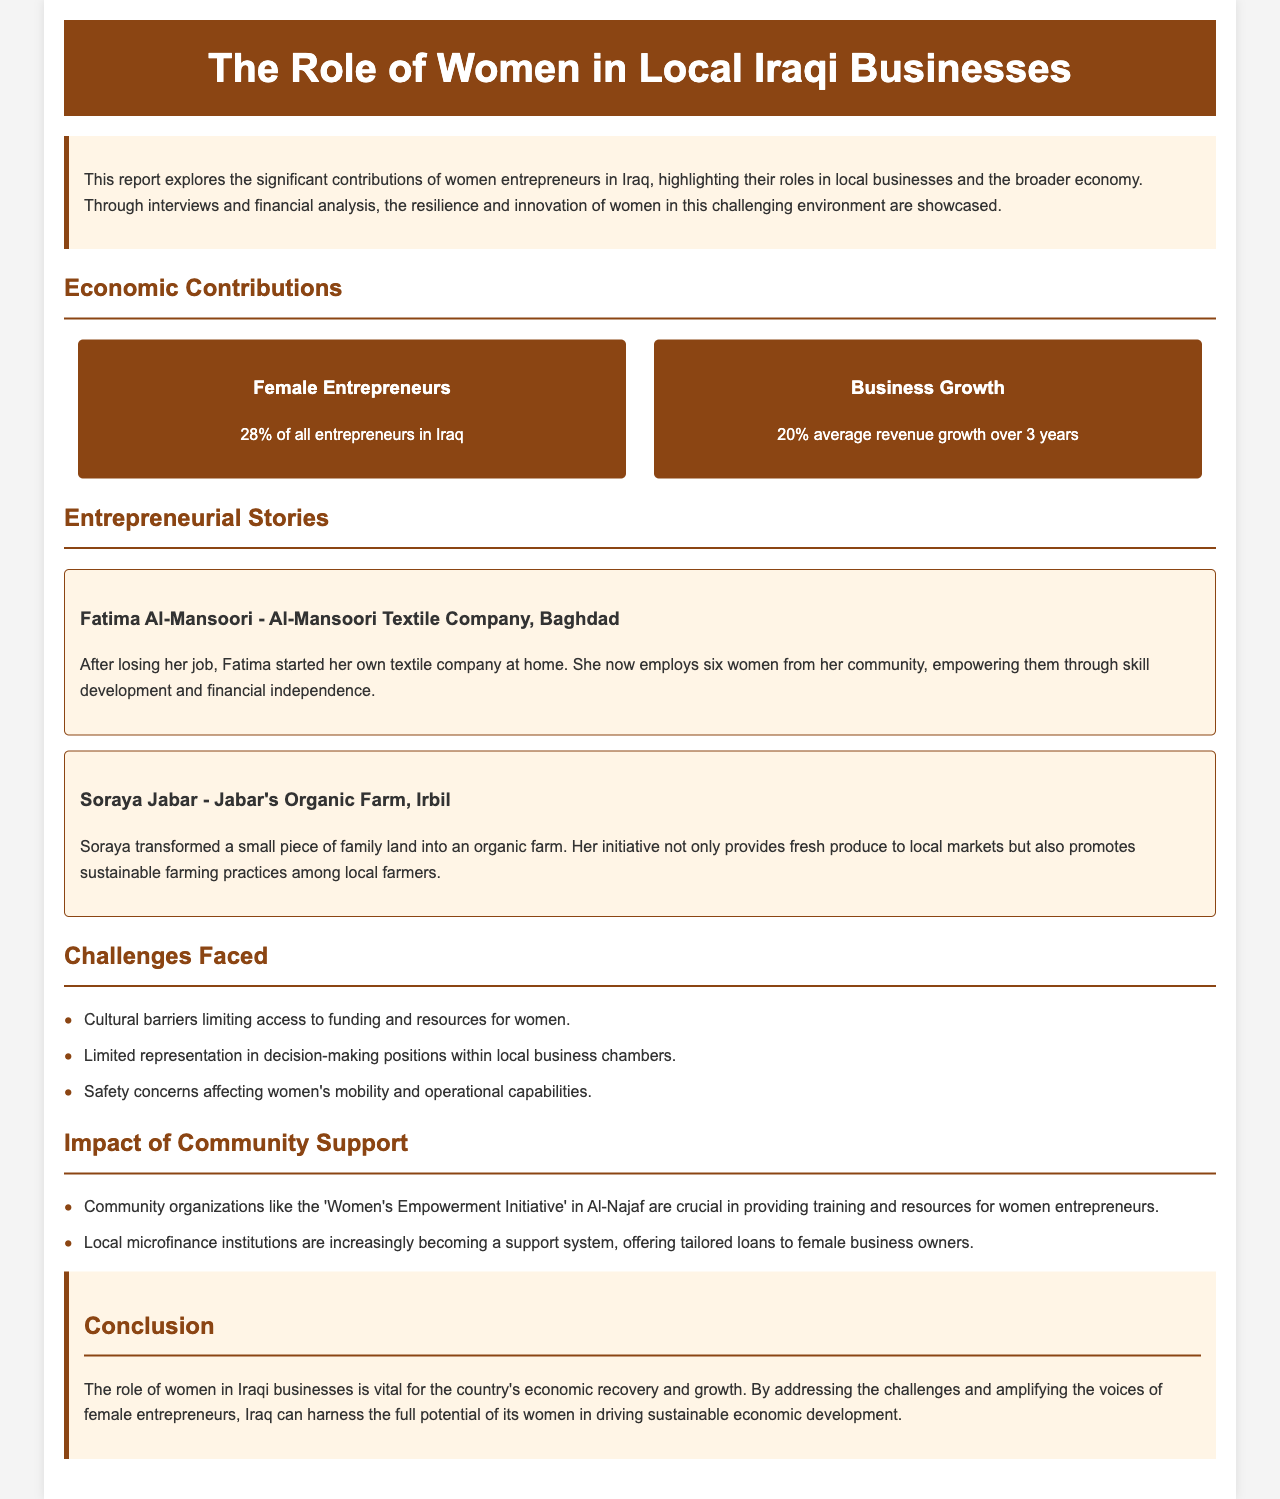What percentage of entrepreneurs in Iraq are female? The document states that 28% of all entrepreneurs in Iraq are female.
Answer: 28% What is the average revenue growth for female-led businesses over three years? The average revenue growth for female-led businesses is 20% over three years.
Answer: 20% Who is the owner of Al-Mansoori Textile Company? The report provides the name Fatima Al-Mansoori as the owner of Al-Mansoori Textile Company.
Answer: Fatima Al-Mansoori What is one challenge faced by women entrepreneurs in Iraq? The document lists cultural barriers limiting access to funding and resources as a challenge faced by women.
Answer: Cultural barriers Which community support initiative is mentioned in the document? The document references the 'Women's Empowerment Initiative' in Al-Najaf as a community support initiative.
Answer: Women's Empowerment Initiative How many women does Fatima Al-Mansoori employ? The report mentions that Fatima employs six women from her community.
Answer: Six women What type of farming does Soraya Jabar promote? The document says that Soraya's farm promotes sustainable farming practices among local farmers.
Answer: Sustainable farming What is a significant economic role of women according to the conclusion? The conclusion states that women's roles are vital for economic recovery and growth.
Answer: Economic recovery and growth 